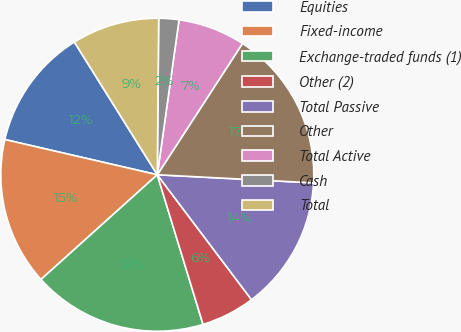<chart> <loc_0><loc_0><loc_500><loc_500><pie_chart><fcel>Equities<fcel>Fixed-income<fcel>Exchange-traded funds (1)<fcel>Other (2)<fcel>Total Passive<fcel>Other<fcel>Total Active<fcel>Cash<fcel>Total<nl><fcel>12.5%<fcel>15.28%<fcel>18.06%<fcel>5.56%<fcel>13.89%<fcel>16.67%<fcel>6.94%<fcel>2.08%<fcel>9.03%<nl></chart> 